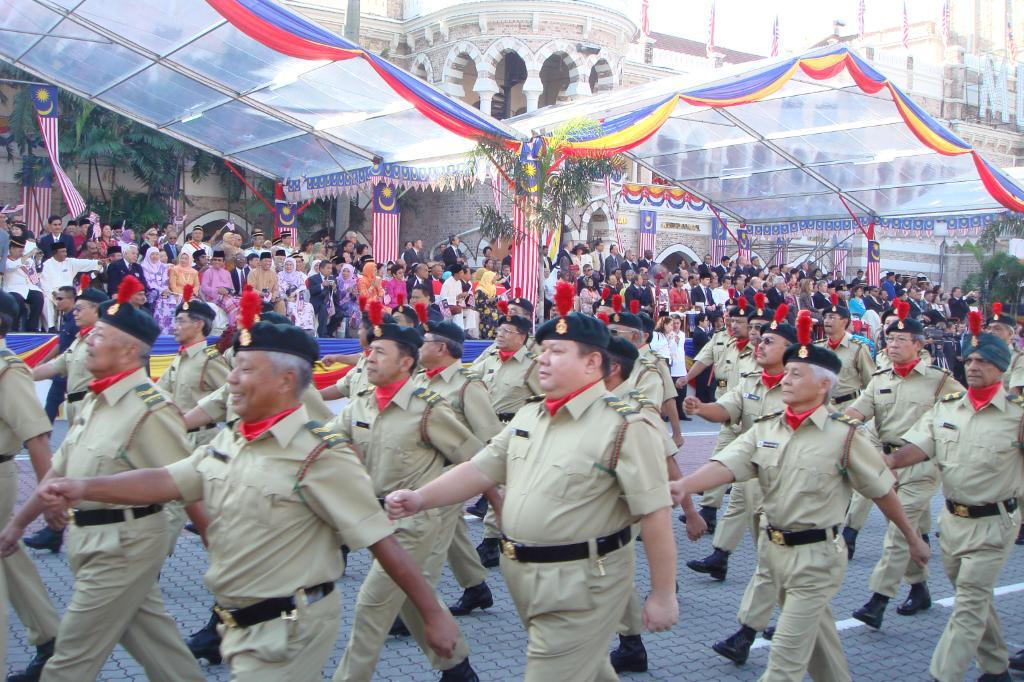Can you describe this image briefly? In this image we can see the police are marching on the road and in the middle, people are sitting. 